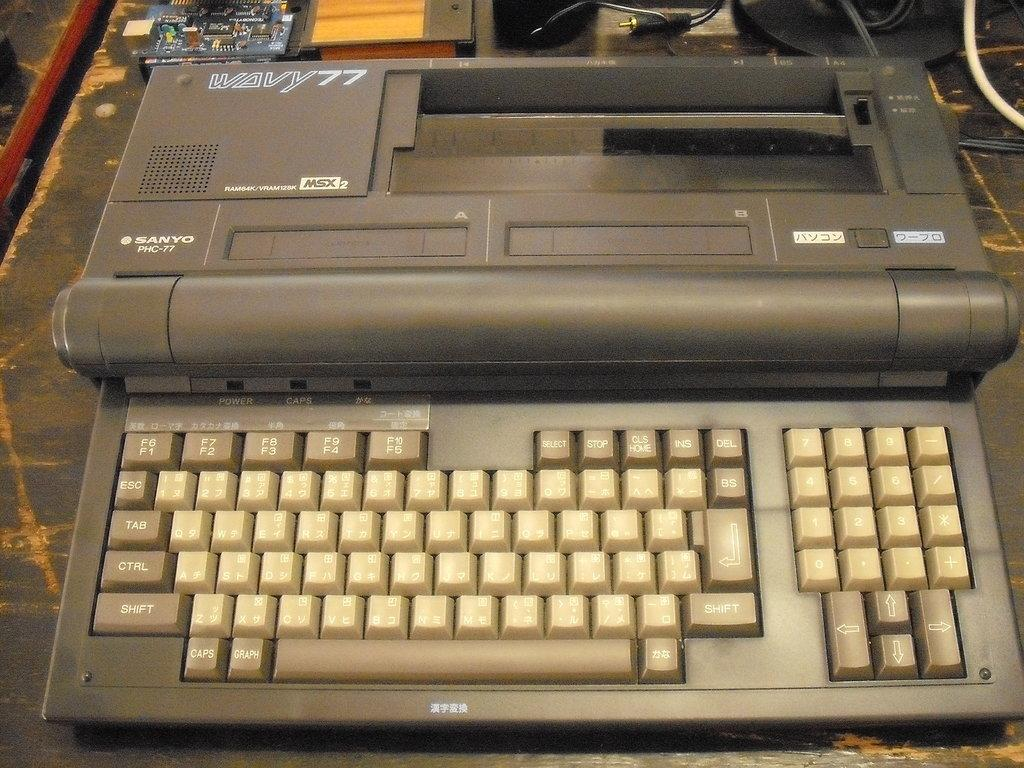Provide a one-sentence caption for the provided image. A tan colored Sanyo PHS-77 electric type writer. 